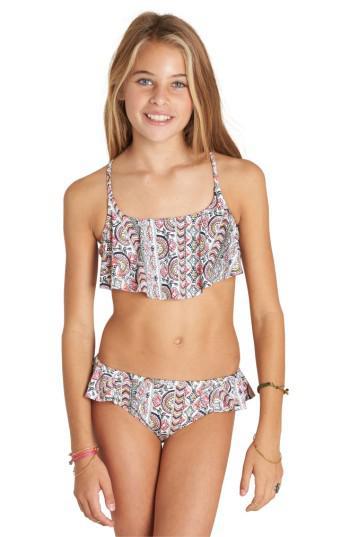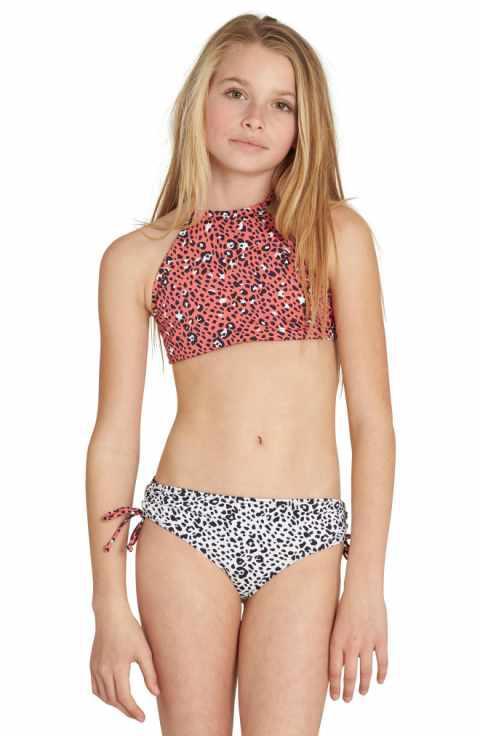The first image is the image on the left, the second image is the image on the right. For the images shown, is this caption "At least one person is wearing a bracelet." true? Answer yes or no. Yes. The first image is the image on the left, the second image is the image on the right. Assess this claim about the two images: "The model in one of the images does not have her right arm hanging by her side.". Correct or not? Answer yes or no. No. 